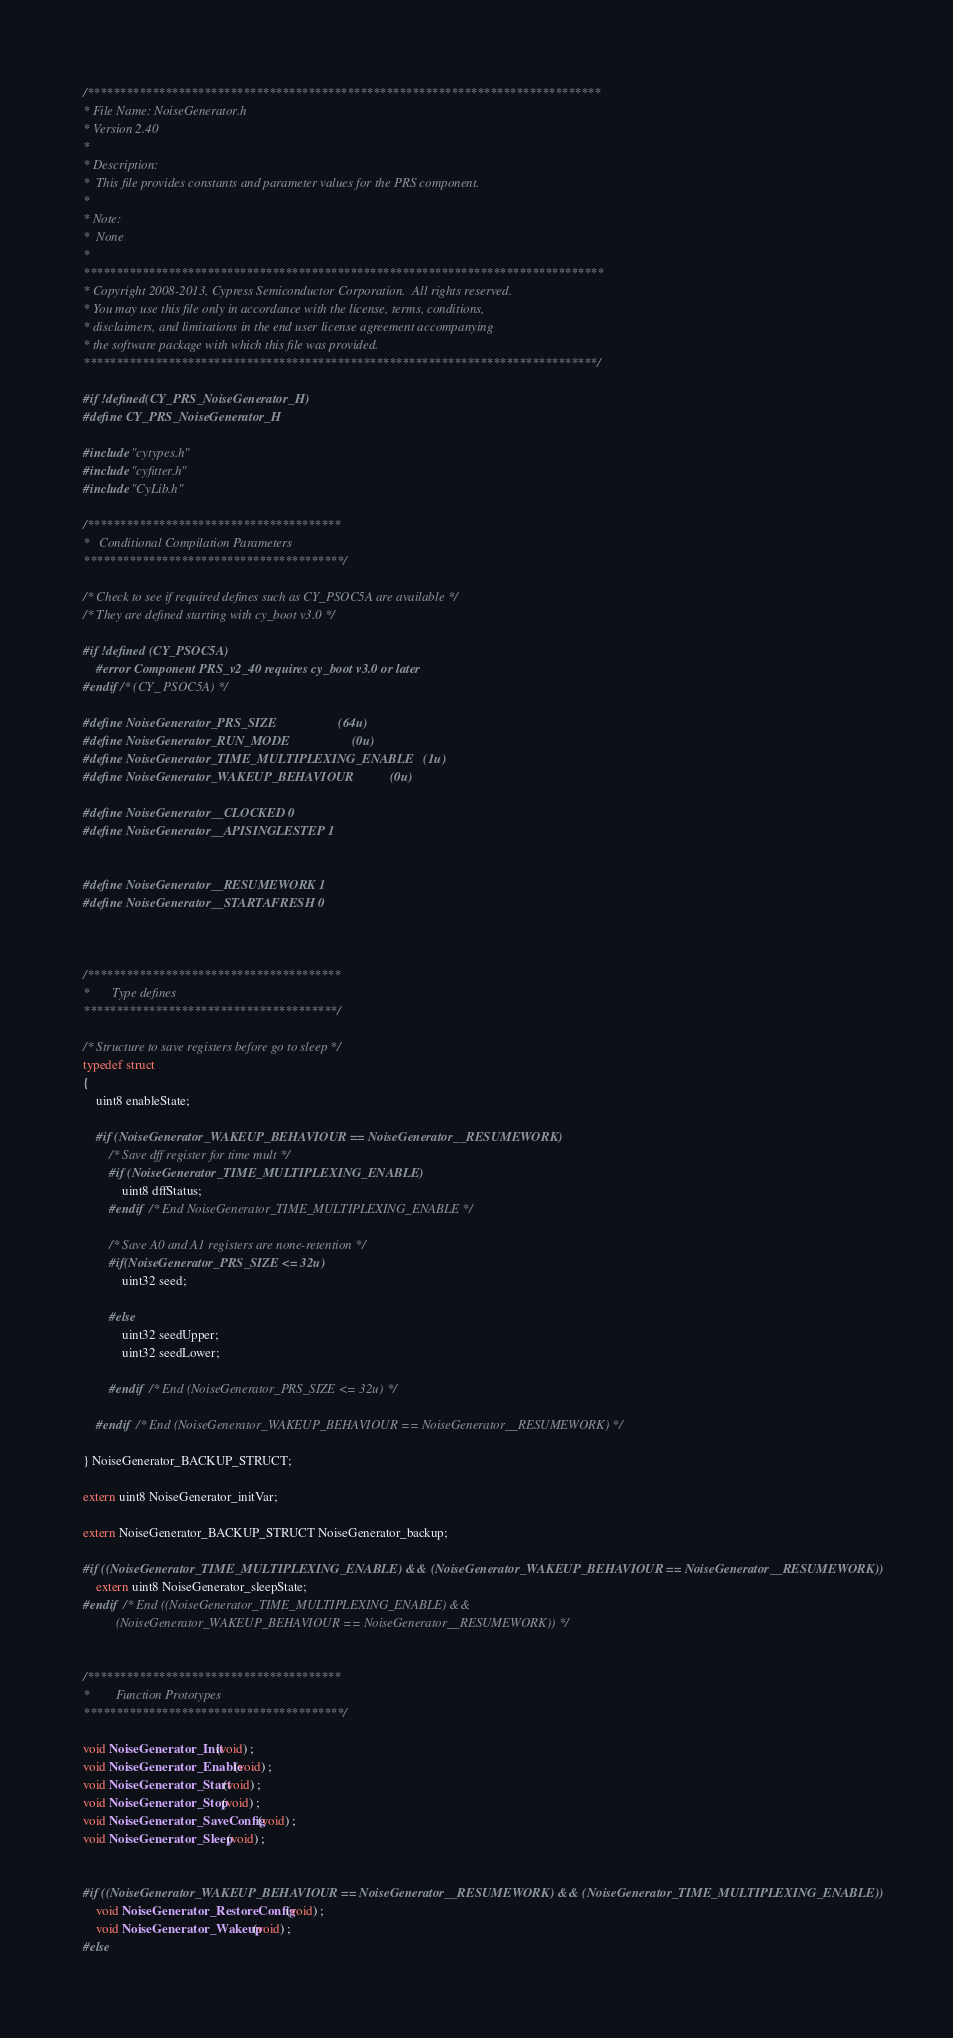Convert code to text. <code><loc_0><loc_0><loc_500><loc_500><_C_>/*******************************************************************************
* File Name: NoiseGenerator.h
* Version 2.40
*
* Description:
*  This file provides constants and parameter values for the PRS component.
*
* Note:
*  None
*
********************************************************************************
* Copyright 2008-2013, Cypress Semiconductor Corporation.  All rights reserved.
* You may use this file only in accordance with the license, terms, conditions, 
* disclaimers, and limitations in the end user license agreement accompanying 
* the software package with which this file was provided.
*******************************************************************************/

#if !defined(CY_PRS_NoiseGenerator_H)
#define CY_PRS_NoiseGenerator_H

#include "cytypes.h"
#include "cyfitter.h"
#include "CyLib.h"

/***************************************
*   Conditional Compilation Parameters
****************************************/

/* Check to see if required defines such as CY_PSOC5A are available */
/* They are defined starting with cy_boot v3.0 */

#if !defined (CY_PSOC5A)
    #error Component PRS_v2_40 requires cy_boot v3.0 or later
#endif /* (CY_ PSOC5A) */

#define NoiseGenerator_PRS_SIZE                   (64u)
#define NoiseGenerator_RUN_MODE                   (0u)
#define NoiseGenerator_TIME_MULTIPLEXING_ENABLE   (1u)
#define NoiseGenerator_WAKEUP_BEHAVIOUR           (0u)

#define NoiseGenerator__CLOCKED 0
#define NoiseGenerator__APISINGLESTEP 1


#define NoiseGenerator__RESUMEWORK 1
#define NoiseGenerator__STARTAFRESH 0



/***************************************
*       Type defines
***************************************/

/* Structure to save registers before go to sleep */
typedef struct
{
    uint8 enableState;
    
    #if (NoiseGenerator_WAKEUP_BEHAVIOUR == NoiseGenerator__RESUMEWORK)
        /* Save dff register for time mult */
        #if (NoiseGenerator_TIME_MULTIPLEXING_ENABLE)
            uint8 dffStatus;
        #endif  /* End NoiseGenerator_TIME_MULTIPLEXING_ENABLE */
    
        /* Save A0 and A1 registers are none-retention */
        #if(NoiseGenerator_PRS_SIZE <= 32u)
            uint32 seed;
            
        #else
            uint32 seedUpper;
            uint32 seedLower;
            
        #endif  /* End (NoiseGenerator_PRS_SIZE <= 32u) */ 
        
    #endif  /* End (NoiseGenerator_WAKEUP_BEHAVIOUR == NoiseGenerator__RESUMEWORK) */
    
} NoiseGenerator_BACKUP_STRUCT;

extern uint8 NoiseGenerator_initVar;

extern NoiseGenerator_BACKUP_STRUCT NoiseGenerator_backup;

#if ((NoiseGenerator_TIME_MULTIPLEXING_ENABLE) && (NoiseGenerator_WAKEUP_BEHAVIOUR == NoiseGenerator__RESUMEWORK))
    extern uint8 NoiseGenerator_sleepState;
#endif  /* End ((NoiseGenerator_TIME_MULTIPLEXING_ENABLE) && 
          (NoiseGenerator_WAKEUP_BEHAVIOUR == NoiseGenerator__RESUMEWORK)) */

                                     
/***************************************
*        Function Prototypes
****************************************/

void NoiseGenerator_Init(void) ;
void NoiseGenerator_Enable(void) ;
void NoiseGenerator_Start(void) ;
void NoiseGenerator_Stop(void) ;
void NoiseGenerator_SaveConfig(void) ;
void NoiseGenerator_Sleep(void) ;


#if ((NoiseGenerator_WAKEUP_BEHAVIOUR == NoiseGenerator__RESUMEWORK) && (NoiseGenerator_TIME_MULTIPLEXING_ENABLE))
    void NoiseGenerator_RestoreConfig(void) ;
    void NoiseGenerator_Wakeup(void) ;
#else</code> 